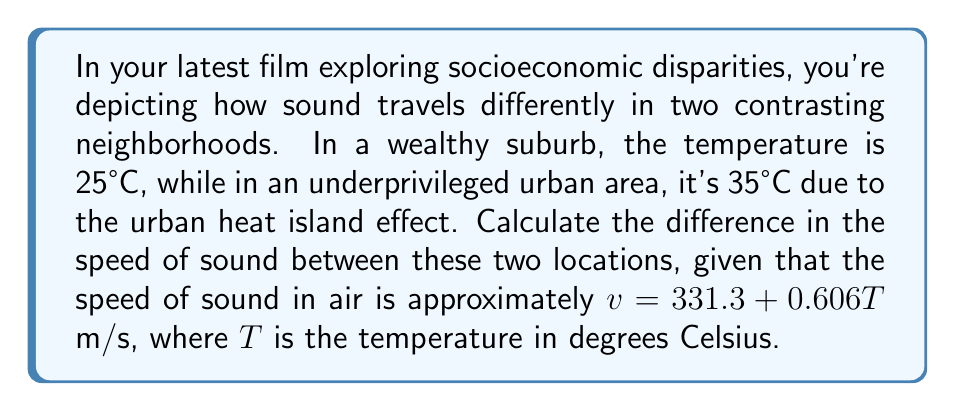What is the answer to this math problem? Let's approach this step-by-step:

1) We're given the formula for the speed of sound in air:
   $v = 331.3 + 0.606T$ m/s, where $T$ is temperature in °C

2) For the wealthy suburb (T = 25°C):
   $v_1 = 331.3 + 0.606(25)$
   $v_1 = 331.3 + 15.15$
   $v_1 = 346.45$ m/s

3) For the underprivileged urban area (T = 35°C):
   $v_2 = 331.3 + 0.606(35)$
   $v_2 = 331.3 + 21.21$
   $v_2 = 352.51$ m/s

4) To find the difference, we subtract:
   $\Delta v = v_2 - v_1$
   $\Delta v = 352.51 - 346.45$
   $\Delta v = 6.06$ m/s

This difference highlights how environmental factors tied to socioeconomic conditions can affect physical phenomena like sound propagation.
Answer: 6.06 m/s 